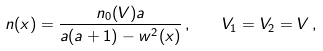<formula> <loc_0><loc_0><loc_500><loc_500>n ( x ) = \frac { n _ { 0 } ( V ) a } { a ( a + 1 ) - w ^ { 2 } ( x ) } \, , \quad V _ { 1 } = V _ { 2 } = V \, ,</formula> 